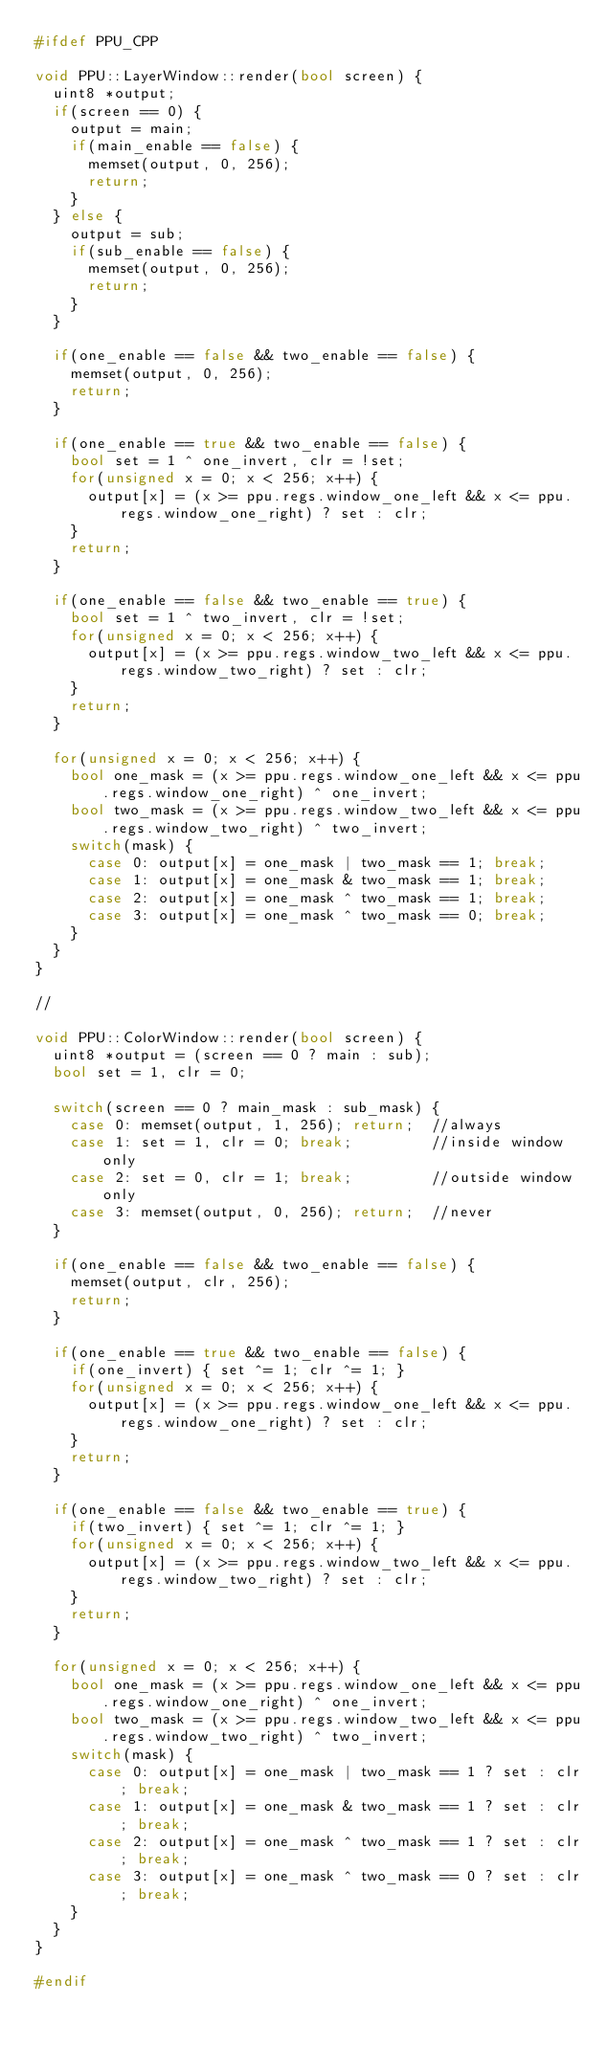<code> <loc_0><loc_0><loc_500><loc_500><_C++_>#ifdef PPU_CPP

void PPU::LayerWindow::render(bool screen) {
  uint8 *output;
  if(screen == 0) {
    output = main;
    if(main_enable == false) {
      memset(output, 0, 256);
      return;
    }
  } else {
    output = sub;
    if(sub_enable == false) {
      memset(output, 0, 256);
      return;
    }
  }

  if(one_enable == false && two_enable == false) {
    memset(output, 0, 256);
    return;
  }

  if(one_enable == true && two_enable == false) {
    bool set = 1 ^ one_invert, clr = !set;
    for(unsigned x = 0; x < 256; x++) {
      output[x] = (x >= ppu.regs.window_one_left && x <= ppu.regs.window_one_right) ? set : clr;
    }
    return;
  }

  if(one_enable == false && two_enable == true) {
    bool set = 1 ^ two_invert, clr = !set;
    for(unsigned x = 0; x < 256; x++) {
      output[x] = (x >= ppu.regs.window_two_left && x <= ppu.regs.window_two_right) ? set : clr;
    }
    return;
  }

  for(unsigned x = 0; x < 256; x++) {
    bool one_mask = (x >= ppu.regs.window_one_left && x <= ppu.regs.window_one_right) ^ one_invert;
    bool two_mask = (x >= ppu.regs.window_two_left && x <= ppu.regs.window_two_right) ^ two_invert;
    switch(mask) {
      case 0: output[x] = one_mask | two_mask == 1; break;
      case 1: output[x] = one_mask & two_mask == 1; break;
      case 2: output[x] = one_mask ^ two_mask == 1; break;
      case 3: output[x] = one_mask ^ two_mask == 0; break;
    }
  }
}

//

void PPU::ColorWindow::render(bool screen) {
  uint8 *output = (screen == 0 ? main : sub);
  bool set = 1, clr = 0;

  switch(screen == 0 ? main_mask : sub_mask) {
    case 0: memset(output, 1, 256); return;  //always
    case 1: set = 1, clr = 0; break;         //inside window only
    case 2: set = 0, clr = 1; break;         //outside window only
    case 3: memset(output, 0, 256); return;  //never
  }

  if(one_enable == false && two_enable == false) {
    memset(output, clr, 256);
    return;
  }

  if(one_enable == true && two_enable == false) {
    if(one_invert) { set ^= 1; clr ^= 1; }
    for(unsigned x = 0; x < 256; x++) {
      output[x] = (x >= ppu.regs.window_one_left && x <= ppu.regs.window_one_right) ? set : clr;
    }
    return;
  }

  if(one_enable == false && two_enable == true) {
    if(two_invert) { set ^= 1; clr ^= 1; }
    for(unsigned x = 0; x < 256; x++) {
      output[x] = (x >= ppu.regs.window_two_left && x <= ppu.regs.window_two_right) ? set : clr;
    }
    return;
  }

  for(unsigned x = 0; x < 256; x++) {
    bool one_mask = (x >= ppu.regs.window_one_left && x <= ppu.regs.window_one_right) ^ one_invert;
    bool two_mask = (x >= ppu.regs.window_two_left && x <= ppu.regs.window_two_right) ^ two_invert;
    switch(mask) {
      case 0: output[x] = one_mask | two_mask == 1 ? set : clr; break;
      case 1: output[x] = one_mask & two_mask == 1 ? set : clr; break;
      case 2: output[x] = one_mask ^ two_mask == 1 ? set : clr; break;
      case 3: output[x] = one_mask ^ two_mask == 0 ? set : clr; break;
    }
  }
}

#endif
</code> 